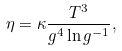Convert formula to latex. <formula><loc_0><loc_0><loc_500><loc_500>\eta = \kappa \frac { T ^ { 3 } } { g ^ { 4 } \ln g ^ { - 1 } } ,</formula> 